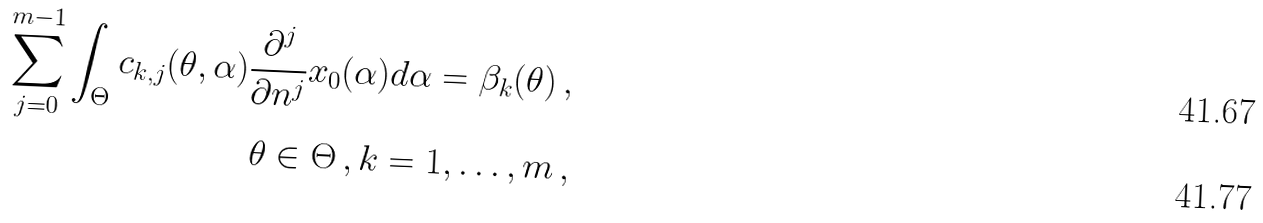<formula> <loc_0><loc_0><loc_500><loc_500>\sum _ { j = 0 } ^ { m - 1 } \int _ { \Theta } c _ { k , j } ( \theta , \alpha ) \frac { \partial ^ { j } } { \partial n ^ { j } } x _ { 0 } ( \alpha ) d \alpha = \beta _ { k } ( \theta ) \, , \\ \theta \in \Theta \, , k = 1 , \dots , m \, ,</formula> 